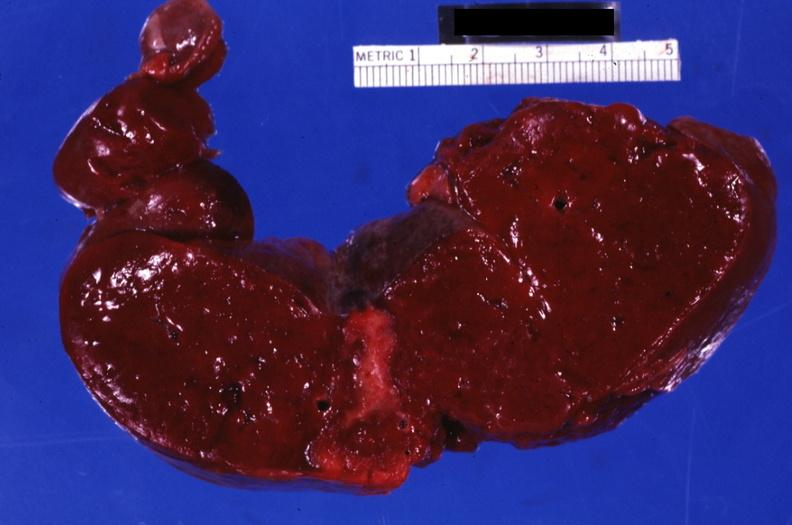where is this part in?
Answer the question using a single word or phrase. Spleen 